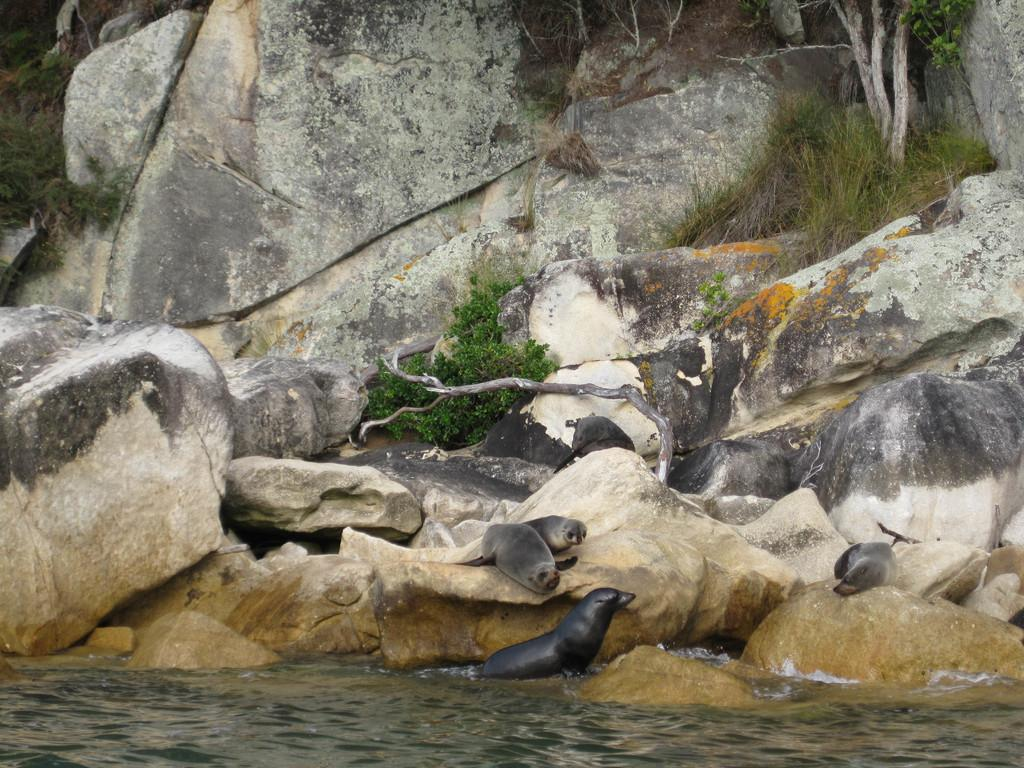What animals can be seen in the image? There are seals in the image. What is the primary element in which the seals are situated? There is water visible in the image, and it might be in a lake. What type of vegetation is visible in the background of the image? There are trees and grass in the background of the image. What type of geological feature is present in the background of the image? There are rocks in the background of the image. What type of office furniture can be seen in the image? There is no office furniture present in the image; it features seals in a water environment. Who is the representative of the seals in the image? There is no representative of the seals in the image, as they are wild animals and not part of a formal organization. 